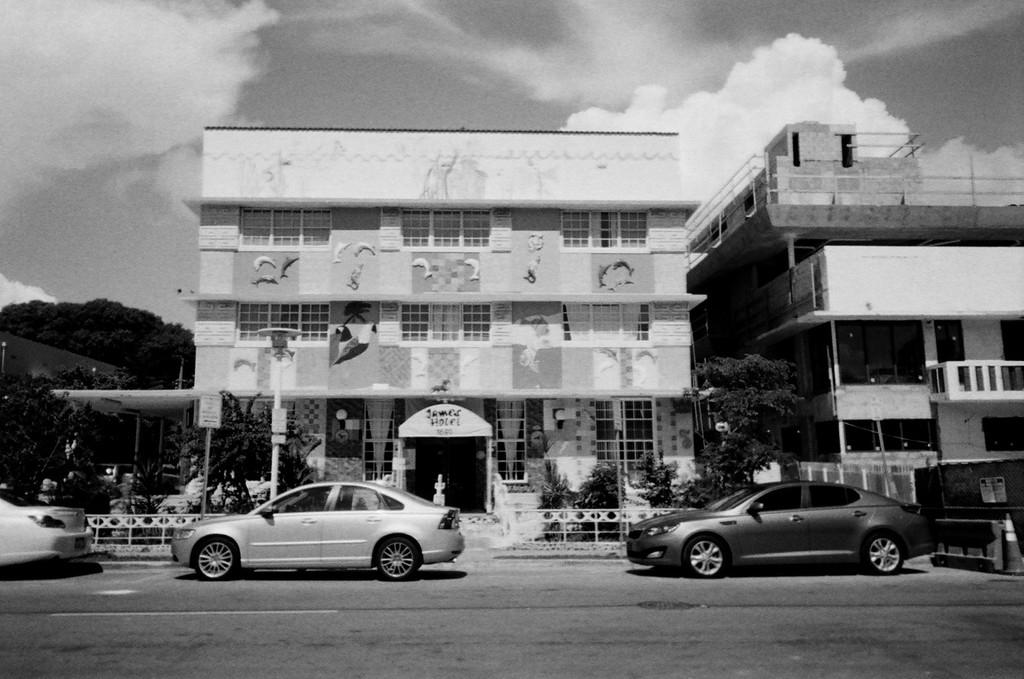What type of structures can be seen in the image? There are buildings in the image. What other natural elements are present in the image? There are trees in the image. What mode of transportation can be seen on the road in the image? There are vehicles on the road in the image. What type of barrier is present in the image? There is a fence in the image. What vertical structures can be seen in the image? There are poles in the image. What is visible in the background of the image? The sky is visible in the background of the image. Where is the box located in the image? There is no box present in the image. What type of chin can be seen on the trees in the image? There are no chins present in the image, as chins are a part of the human face and not a characteristic of trees. 